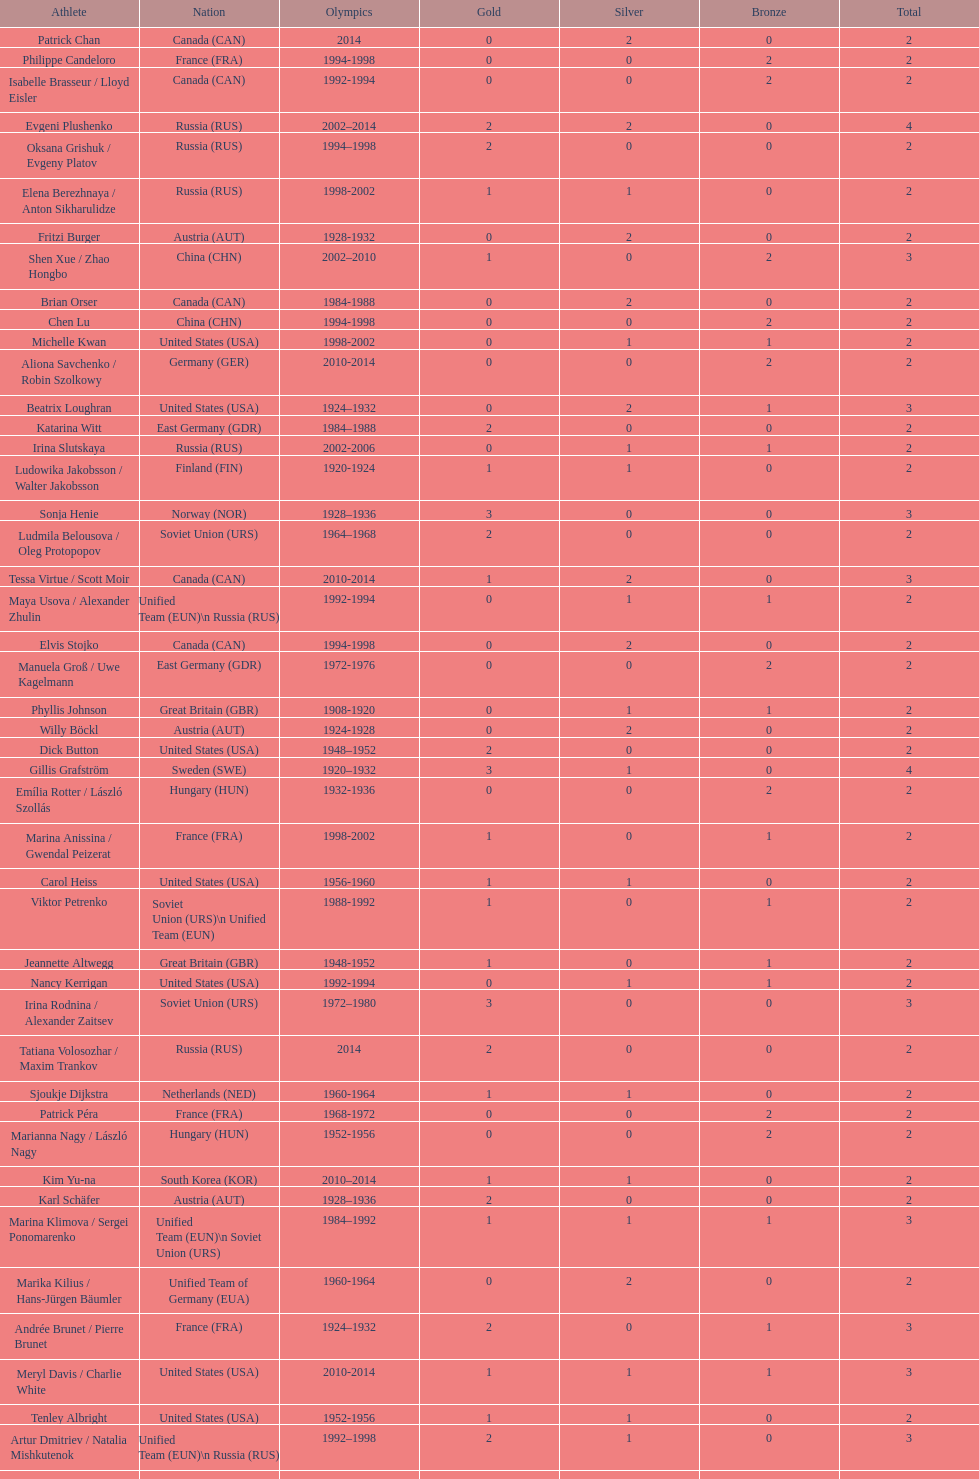How many silver medals did evgeni plushenko get? 2. 